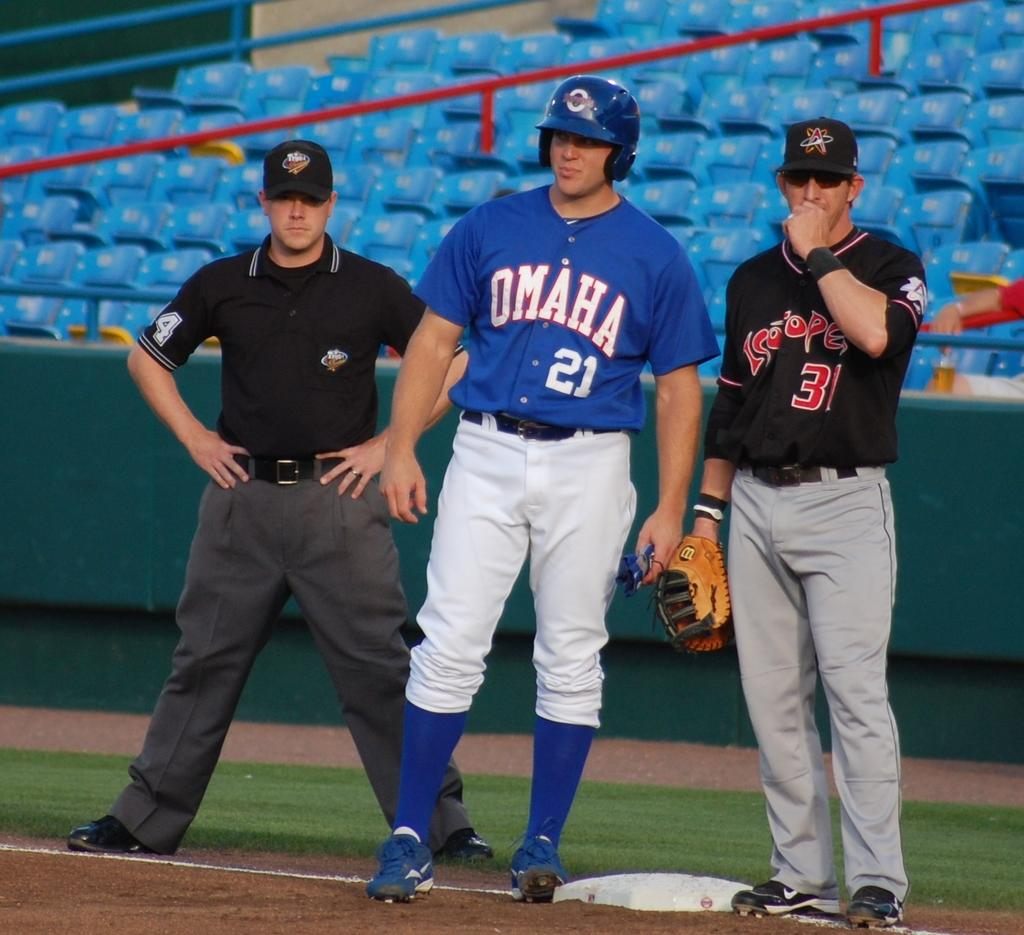Provide a one-sentence caption for the provided image. A group of baseball players are standing by a base and one player's shirt says Omaha. 